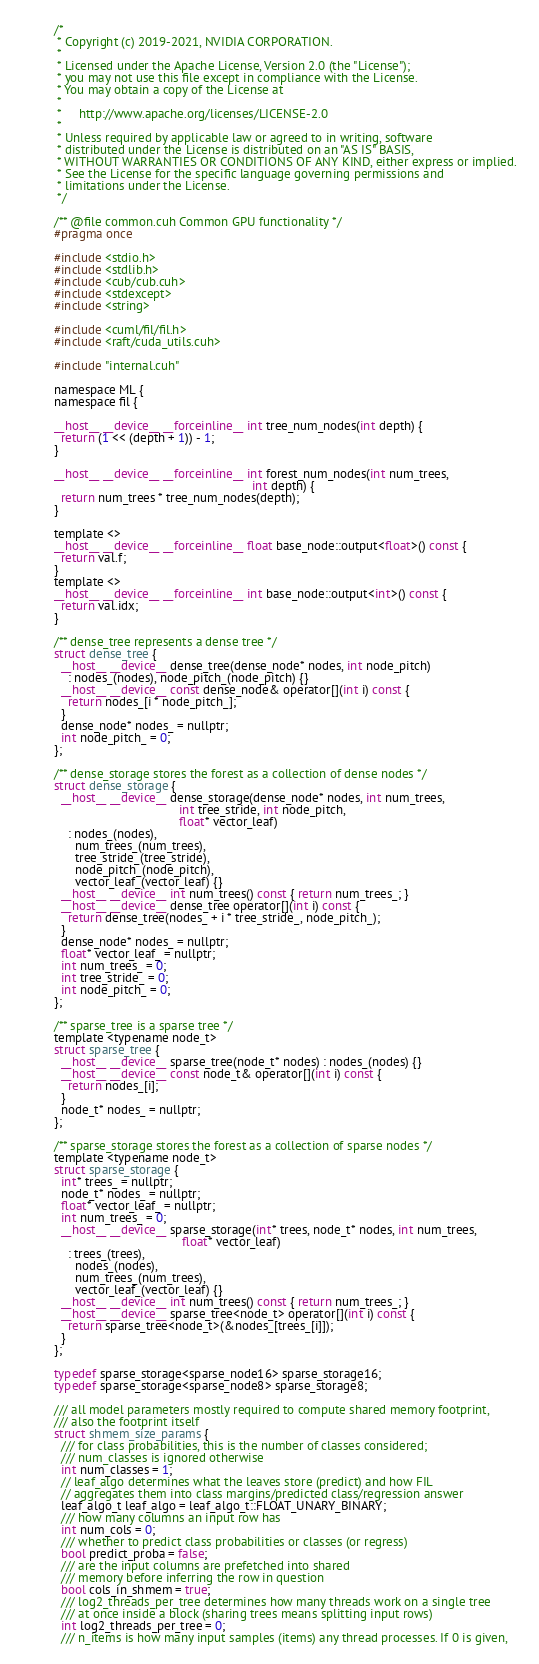Convert code to text. <code><loc_0><loc_0><loc_500><loc_500><_Cuda_>/*
 * Copyright (c) 2019-2021, NVIDIA CORPORATION.
 *
 * Licensed under the Apache License, Version 2.0 (the "License");
 * you may not use this file except in compliance with the License.
 * You may obtain a copy of the License at
 *
 *     http://www.apache.org/licenses/LICENSE-2.0
 *
 * Unless required by applicable law or agreed to in writing, software
 * distributed under the License is distributed on an "AS IS" BASIS,
 * WITHOUT WARRANTIES OR CONDITIONS OF ANY KIND, either express or implied.
 * See the License for the specific language governing permissions and
 * limitations under the License.
 */

/** @file common.cuh Common GPU functionality */
#pragma once

#include <stdio.h>
#include <stdlib.h>
#include <cub/cub.cuh>
#include <stdexcept>
#include <string>

#include <cuml/fil/fil.h>
#include <raft/cuda_utils.cuh>

#include "internal.cuh"

namespace ML {
namespace fil {

__host__ __device__ __forceinline__ int tree_num_nodes(int depth) {
  return (1 << (depth + 1)) - 1;
}

__host__ __device__ __forceinline__ int forest_num_nodes(int num_trees,
                                                         int depth) {
  return num_trees * tree_num_nodes(depth);
}

template <>
__host__ __device__ __forceinline__ float base_node::output<float>() const {
  return val.f;
}
template <>
__host__ __device__ __forceinline__ int base_node::output<int>() const {
  return val.idx;
}

/** dense_tree represents a dense tree */
struct dense_tree {
  __host__ __device__ dense_tree(dense_node* nodes, int node_pitch)
    : nodes_(nodes), node_pitch_(node_pitch) {}
  __host__ __device__ const dense_node& operator[](int i) const {
    return nodes_[i * node_pitch_];
  }
  dense_node* nodes_ = nullptr;
  int node_pitch_ = 0;
};

/** dense_storage stores the forest as a collection of dense nodes */
struct dense_storage {
  __host__ __device__ dense_storage(dense_node* nodes, int num_trees,
                                    int tree_stride, int node_pitch,
                                    float* vector_leaf)
    : nodes_(nodes),
      num_trees_(num_trees),
      tree_stride_(tree_stride),
      node_pitch_(node_pitch),
      vector_leaf_(vector_leaf) {}
  __host__ __device__ int num_trees() const { return num_trees_; }
  __host__ __device__ dense_tree operator[](int i) const {
    return dense_tree(nodes_ + i * tree_stride_, node_pitch_);
  }
  dense_node* nodes_ = nullptr;
  float* vector_leaf_ = nullptr;
  int num_trees_ = 0;
  int tree_stride_ = 0;
  int node_pitch_ = 0;
};

/** sparse_tree is a sparse tree */
template <typename node_t>
struct sparse_tree {
  __host__ __device__ sparse_tree(node_t* nodes) : nodes_(nodes) {}
  __host__ __device__ const node_t& operator[](int i) const {
    return nodes_[i];
  }
  node_t* nodes_ = nullptr;
};

/** sparse_storage stores the forest as a collection of sparse nodes */
template <typename node_t>
struct sparse_storage {
  int* trees_ = nullptr;
  node_t* nodes_ = nullptr;
  float* vector_leaf_ = nullptr;
  int num_trees_ = 0;
  __host__ __device__ sparse_storage(int* trees, node_t* nodes, int num_trees,
                                     float* vector_leaf)
    : trees_(trees),
      nodes_(nodes),
      num_trees_(num_trees),
      vector_leaf_(vector_leaf) {}
  __host__ __device__ int num_trees() const { return num_trees_; }
  __host__ __device__ sparse_tree<node_t> operator[](int i) const {
    return sparse_tree<node_t>(&nodes_[trees_[i]]);
  }
};

typedef sparse_storage<sparse_node16> sparse_storage16;
typedef sparse_storage<sparse_node8> sparse_storage8;

/// all model parameters mostly required to compute shared memory footprint,
/// also the footprint itself
struct shmem_size_params {
  /// for class probabilities, this is the number of classes considered;
  /// num_classes is ignored otherwise
  int num_classes = 1;
  // leaf_algo determines what the leaves store (predict) and how FIL
  // aggregates them into class margins/predicted class/regression answer
  leaf_algo_t leaf_algo = leaf_algo_t::FLOAT_UNARY_BINARY;
  /// how many columns an input row has
  int num_cols = 0;
  /// whether to predict class probabilities or classes (or regress)
  bool predict_proba = false;
  /// are the input columns are prefetched into shared
  /// memory before inferring the row in question
  bool cols_in_shmem = true;
  /// log2_threads_per_tree determines how many threads work on a single tree
  /// at once inside a block (sharing trees means splitting input rows)
  int log2_threads_per_tree = 0;
  /// n_items is how many input samples (items) any thread processes. If 0 is given,</code> 